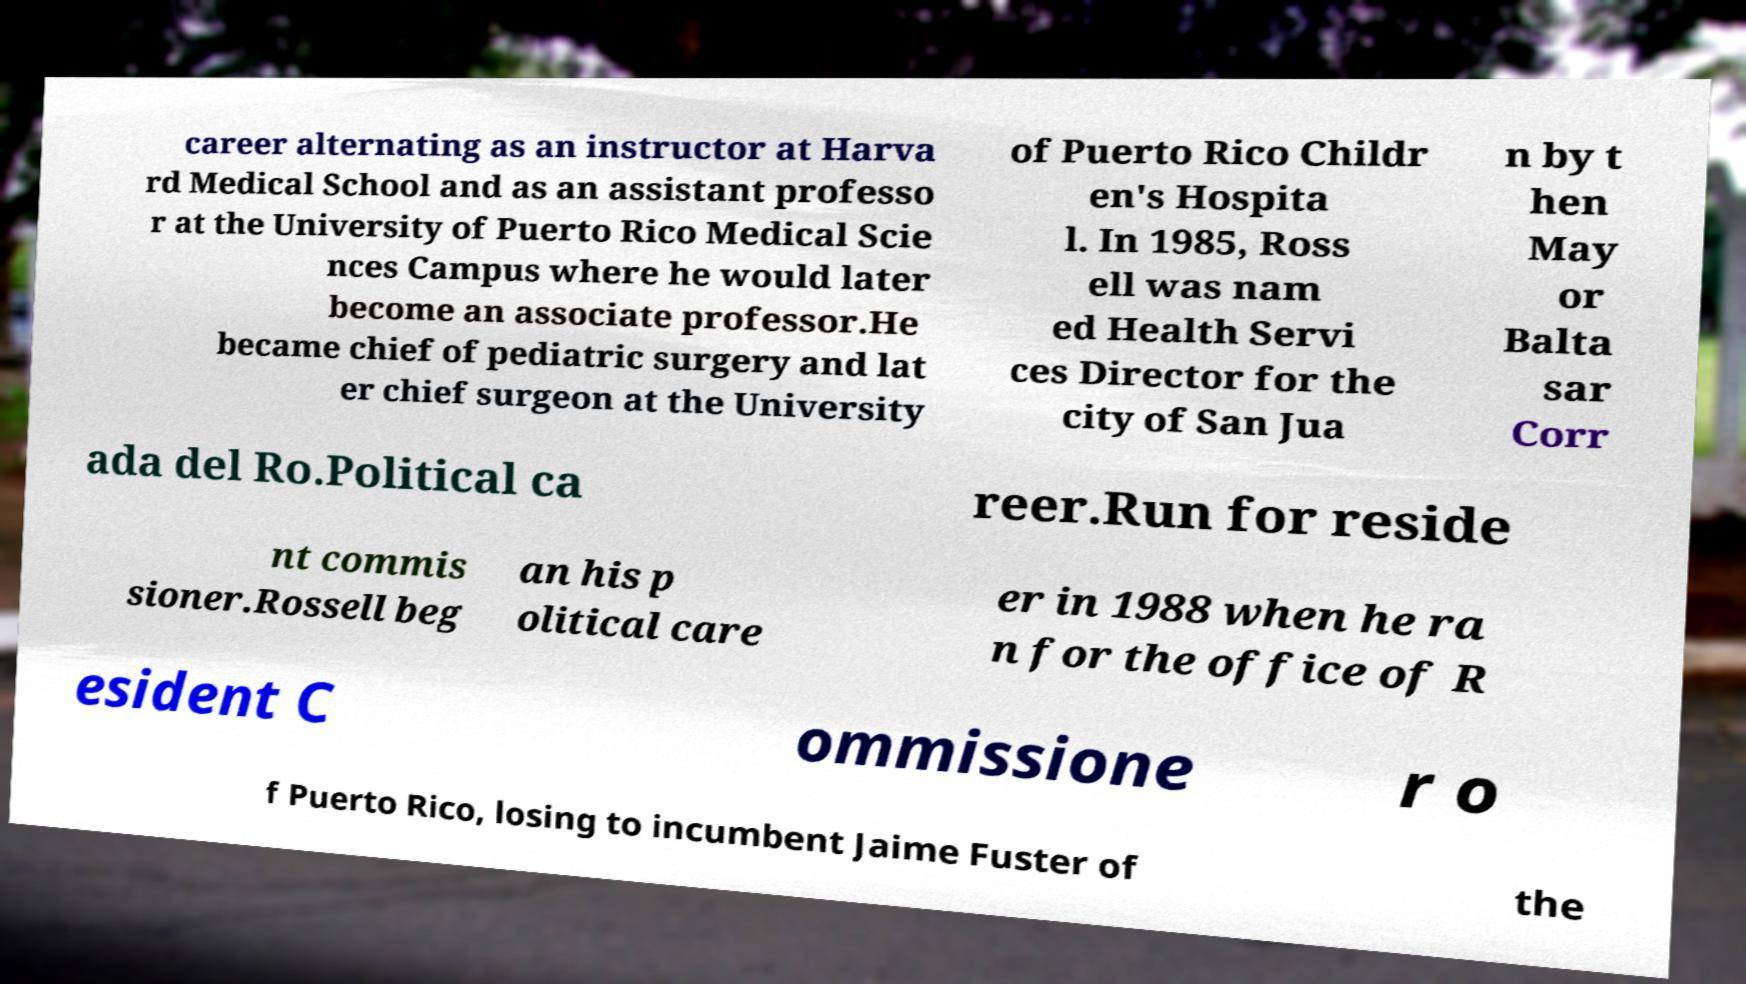Please read and relay the text visible in this image. What does it say? career alternating as an instructor at Harva rd Medical School and as an assistant professo r at the University of Puerto Rico Medical Scie nces Campus where he would later become an associate professor.He became chief of pediatric surgery and lat er chief surgeon at the University of Puerto Rico Childr en's Hospita l. In 1985, Ross ell was nam ed Health Servi ces Director for the city of San Jua n by t hen May or Balta sar Corr ada del Ro.Political ca reer.Run for reside nt commis sioner.Rossell beg an his p olitical care er in 1988 when he ra n for the office of R esident C ommissione r o f Puerto Rico, losing to incumbent Jaime Fuster of the 